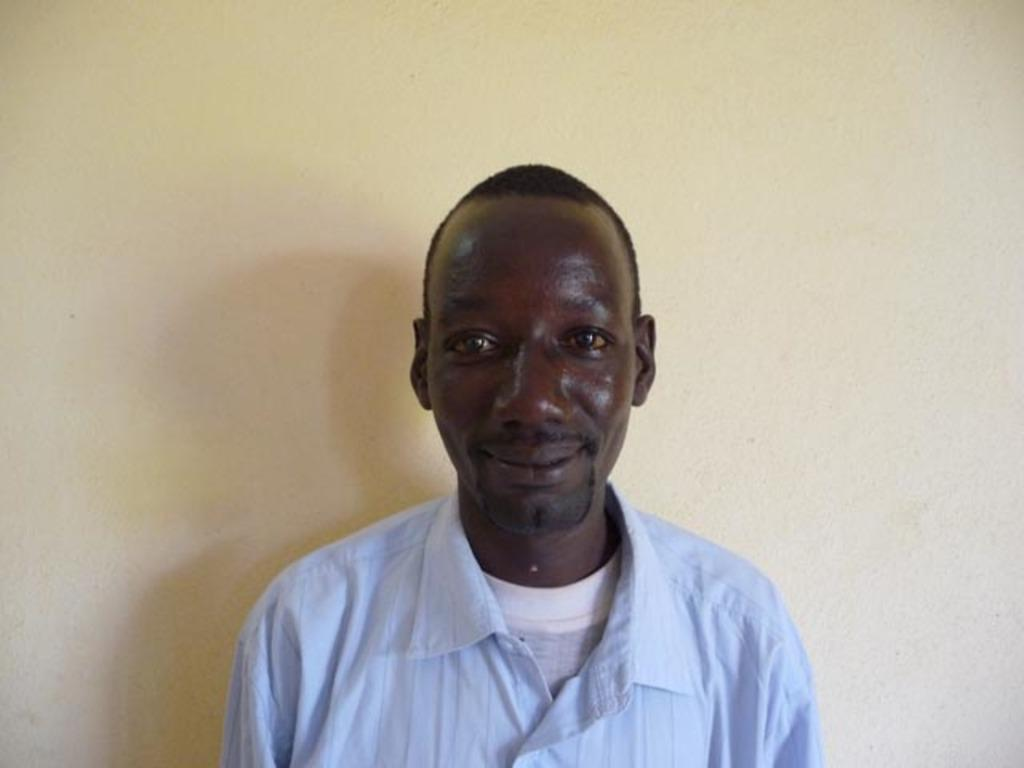What is the man in the image doing? The man is standing in the image. What is the man's facial expression? The man is smiling. What type of clothing is the man wearing? The man is wearing a T-shirt and a shirt. What can be seen behind the man in the image? There is a wall in the image. What is the color of the wall? The wall is light yellow in color. What type of cup can be seen bursting on the wall in the image? There is no cup or bursting action present in the image. Is there a farm visible in the background of the image? No, there is no farm visible in the image; only a wall is present in the background. 